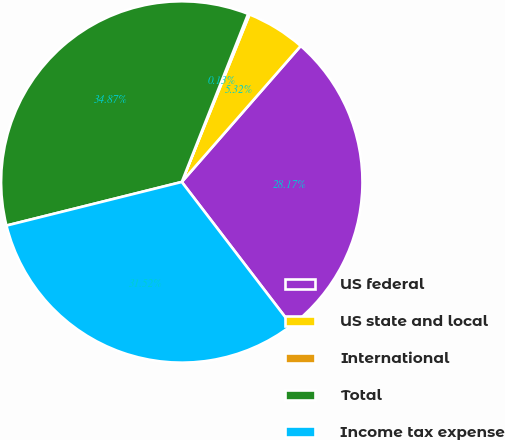<chart> <loc_0><loc_0><loc_500><loc_500><pie_chart><fcel>US federal<fcel>US state and local<fcel>International<fcel>Total<fcel>Income tax expense<nl><fcel>28.17%<fcel>5.32%<fcel>0.13%<fcel>34.87%<fcel>31.52%<nl></chart> 